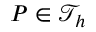Convert formula to latex. <formula><loc_0><loc_0><loc_500><loc_500>{ P } \in \mathcal { T } _ { h }</formula> 